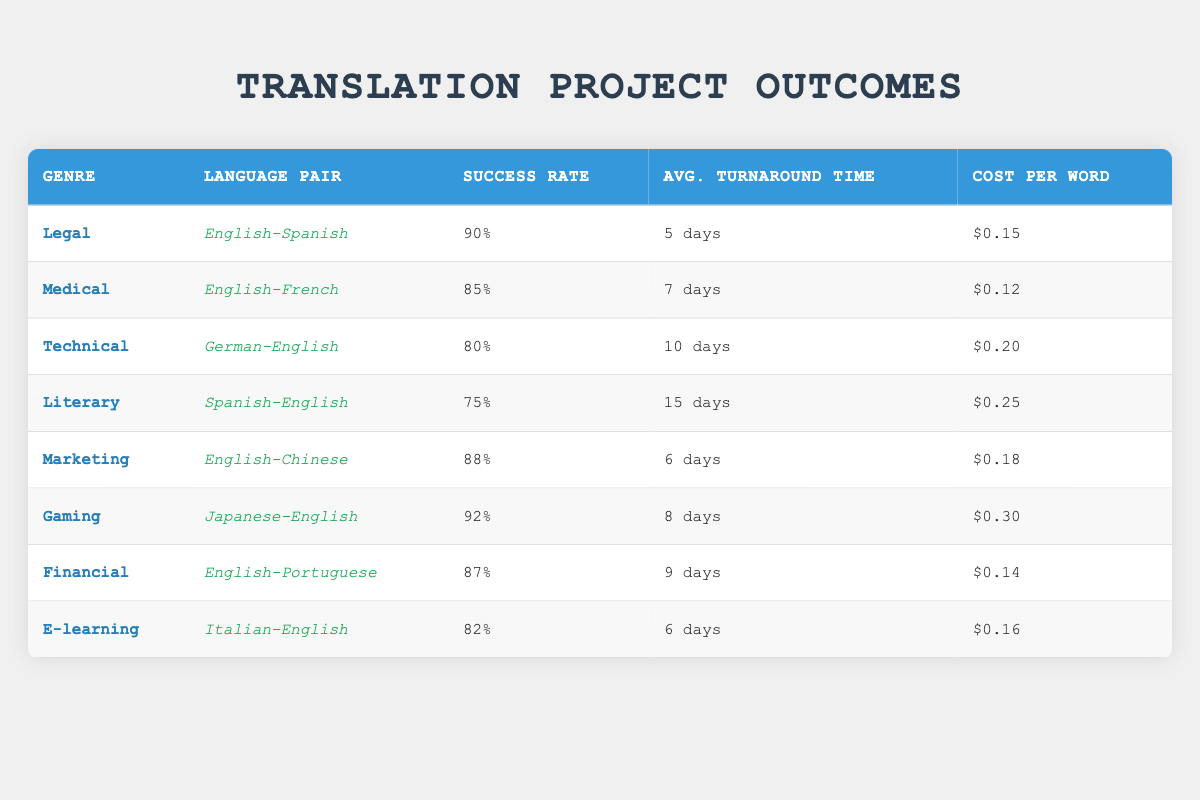What is the success rate for Legal translations in the English-Spanish pair? The table indicates that the success rate for the Legal genre with the English-Spanish language pair is 90.
Answer: 90 What is the average turnaround time for Gaming projects? The average turnaround time listed for Gaming (Japanese-English) is 8 days.
Answer: 8 days Which genre has the highest success rate? By comparing the success rates, Gaming has the highest at 92, followed by Legal at 90.
Answer: Gaming Is the cost per word for Medical translations less than that for Literary translations? The cost per word for the Medical genre (0.12) is less than for Literary (0.25).
Answer: Yes What is the average cost per word for all projects? The total cost per word is (0.15 + 0.12 + 0.20 + 0.25 + 0.18 + 0.30 + 0.14 + 0.16) = 1.40. There are 8 projects, so the average cost per word is 1.40 / 8 = 0.175.
Answer: 0.175 Does Financial have a higher success rate than Medical? Financial has a success rate of 87, while Medical has 85, so Financial does have a higher rate.
Answer: Yes What is the total average turnaround time for translations in the genres that have a success rate above 85? The genres with a success rate above 85 are Legal (5), Marketing (6), Gaming (8), and Financial (9). The total average turnaround time is (5 + 6 + 8 + 9) = 28 days for 4 projects, which gives 28 / 4 = 7 days.
Answer: 7 days Which language pair had the longest average turnaround time? The longest average turnaround time is seen in the Literary genre (Spanish-English) with 15 days.
Answer: 15 days What is the success rate for the Technical genre compared to E-learning? The success rate for Technical is 80, while E-learning has a rate of 82, so E-learning is higher than Technical.
Answer: E-learning is higher 